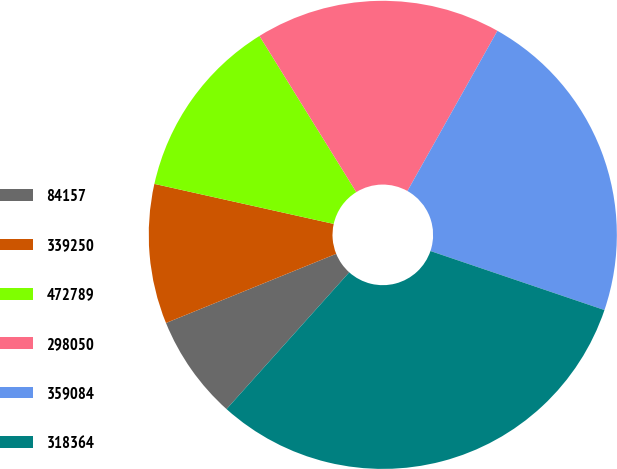Convert chart to OTSL. <chart><loc_0><loc_0><loc_500><loc_500><pie_chart><fcel>84157<fcel>339250<fcel>472789<fcel>298050<fcel>359084<fcel>318364<nl><fcel>7.22%<fcel>9.64%<fcel>12.67%<fcel>16.98%<fcel>22.06%<fcel>31.43%<nl></chart> 